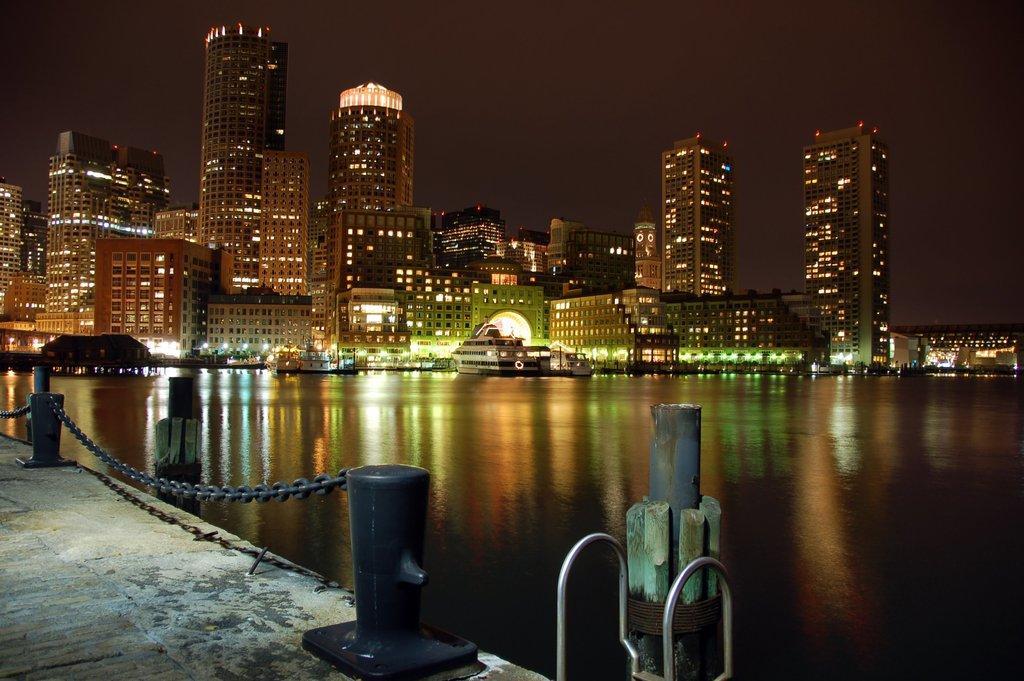How would you summarize this image in a sentence or two? On the left side, there is a floor on which, there is a fencing. In the background, there are boats on the water, there are buildings which are having lights and there is sky. 